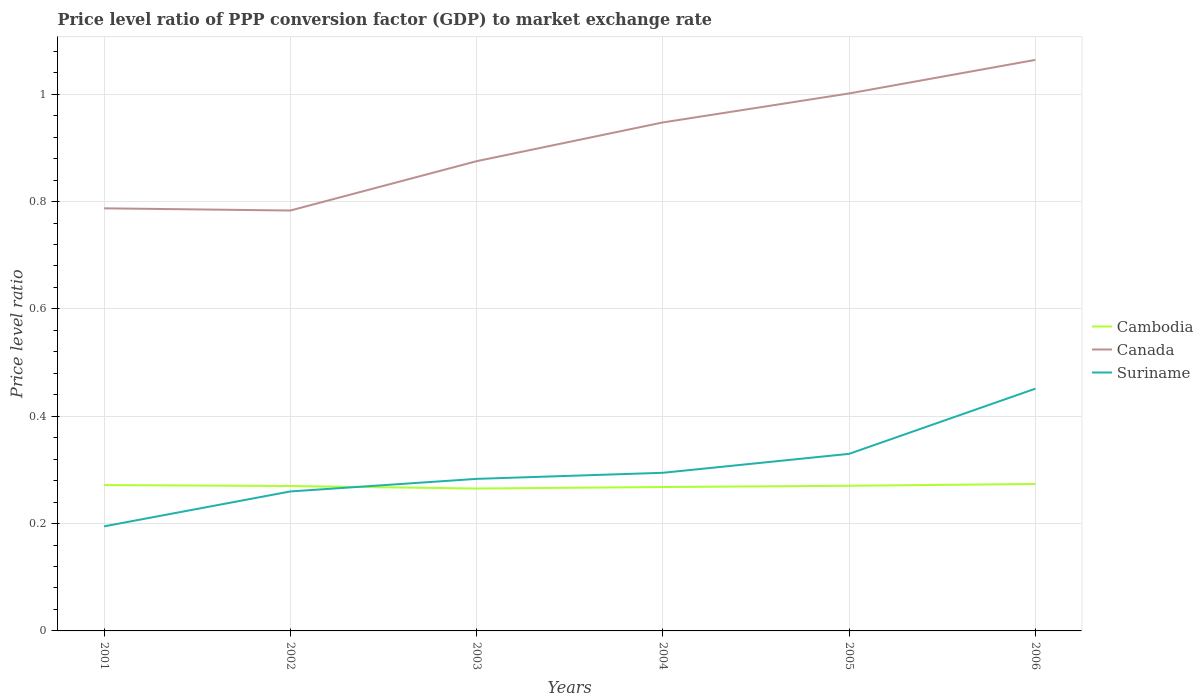How many different coloured lines are there?
Your response must be concise. 3. Is the number of lines equal to the number of legend labels?
Give a very brief answer. Yes. Across all years, what is the maximum price level ratio in Cambodia?
Your response must be concise. 0.27. In which year was the price level ratio in Suriname maximum?
Ensure brevity in your answer.  2001. What is the total price level ratio in Suriname in the graph?
Your answer should be compact. -0.1. What is the difference between the highest and the second highest price level ratio in Cambodia?
Keep it short and to the point. 0.01. What is the difference between the highest and the lowest price level ratio in Canada?
Provide a short and direct response. 3. How many years are there in the graph?
Make the answer very short. 6. What is the difference between two consecutive major ticks on the Y-axis?
Give a very brief answer. 0.2. Are the values on the major ticks of Y-axis written in scientific E-notation?
Make the answer very short. No. How many legend labels are there?
Offer a terse response. 3. How are the legend labels stacked?
Your response must be concise. Vertical. What is the title of the graph?
Your answer should be very brief. Price level ratio of PPP conversion factor (GDP) to market exchange rate. What is the label or title of the Y-axis?
Keep it short and to the point. Price level ratio. What is the Price level ratio of Cambodia in 2001?
Keep it short and to the point. 0.27. What is the Price level ratio in Canada in 2001?
Offer a very short reply. 0.79. What is the Price level ratio in Suriname in 2001?
Your answer should be very brief. 0.19. What is the Price level ratio in Cambodia in 2002?
Your answer should be compact. 0.27. What is the Price level ratio of Canada in 2002?
Provide a succinct answer. 0.78. What is the Price level ratio of Suriname in 2002?
Provide a succinct answer. 0.26. What is the Price level ratio of Cambodia in 2003?
Make the answer very short. 0.27. What is the Price level ratio of Canada in 2003?
Offer a terse response. 0.88. What is the Price level ratio in Suriname in 2003?
Provide a short and direct response. 0.28. What is the Price level ratio of Cambodia in 2004?
Give a very brief answer. 0.27. What is the Price level ratio in Canada in 2004?
Ensure brevity in your answer.  0.95. What is the Price level ratio in Suriname in 2004?
Provide a short and direct response. 0.29. What is the Price level ratio in Cambodia in 2005?
Offer a terse response. 0.27. What is the Price level ratio of Canada in 2005?
Offer a terse response. 1. What is the Price level ratio in Suriname in 2005?
Give a very brief answer. 0.33. What is the Price level ratio in Cambodia in 2006?
Provide a succinct answer. 0.27. What is the Price level ratio of Canada in 2006?
Give a very brief answer. 1.06. What is the Price level ratio in Suriname in 2006?
Your answer should be compact. 0.45. Across all years, what is the maximum Price level ratio in Cambodia?
Your response must be concise. 0.27. Across all years, what is the maximum Price level ratio in Canada?
Provide a succinct answer. 1.06. Across all years, what is the maximum Price level ratio of Suriname?
Give a very brief answer. 0.45. Across all years, what is the minimum Price level ratio of Cambodia?
Your answer should be compact. 0.27. Across all years, what is the minimum Price level ratio in Canada?
Offer a terse response. 0.78. Across all years, what is the minimum Price level ratio of Suriname?
Make the answer very short. 0.19. What is the total Price level ratio of Cambodia in the graph?
Offer a very short reply. 1.62. What is the total Price level ratio in Canada in the graph?
Your answer should be very brief. 5.46. What is the total Price level ratio in Suriname in the graph?
Make the answer very short. 1.81. What is the difference between the Price level ratio in Cambodia in 2001 and that in 2002?
Your response must be concise. 0. What is the difference between the Price level ratio in Canada in 2001 and that in 2002?
Give a very brief answer. 0. What is the difference between the Price level ratio of Suriname in 2001 and that in 2002?
Ensure brevity in your answer.  -0.07. What is the difference between the Price level ratio of Cambodia in 2001 and that in 2003?
Offer a very short reply. 0.01. What is the difference between the Price level ratio in Canada in 2001 and that in 2003?
Keep it short and to the point. -0.09. What is the difference between the Price level ratio of Suriname in 2001 and that in 2003?
Your answer should be compact. -0.09. What is the difference between the Price level ratio in Cambodia in 2001 and that in 2004?
Provide a succinct answer. 0. What is the difference between the Price level ratio in Canada in 2001 and that in 2004?
Offer a terse response. -0.16. What is the difference between the Price level ratio of Suriname in 2001 and that in 2004?
Your answer should be very brief. -0.1. What is the difference between the Price level ratio in Cambodia in 2001 and that in 2005?
Provide a short and direct response. 0. What is the difference between the Price level ratio in Canada in 2001 and that in 2005?
Your answer should be compact. -0.21. What is the difference between the Price level ratio of Suriname in 2001 and that in 2005?
Give a very brief answer. -0.14. What is the difference between the Price level ratio in Cambodia in 2001 and that in 2006?
Your answer should be compact. -0. What is the difference between the Price level ratio of Canada in 2001 and that in 2006?
Offer a very short reply. -0.28. What is the difference between the Price level ratio of Suriname in 2001 and that in 2006?
Make the answer very short. -0.26. What is the difference between the Price level ratio of Cambodia in 2002 and that in 2003?
Offer a terse response. 0. What is the difference between the Price level ratio of Canada in 2002 and that in 2003?
Offer a very short reply. -0.09. What is the difference between the Price level ratio of Suriname in 2002 and that in 2003?
Provide a succinct answer. -0.02. What is the difference between the Price level ratio of Cambodia in 2002 and that in 2004?
Ensure brevity in your answer.  0. What is the difference between the Price level ratio in Canada in 2002 and that in 2004?
Keep it short and to the point. -0.16. What is the difference between the Price level ratio in Suriname in 2002 and that in 2004?
Provide a succinct answer. -0.03. What is the difference between the Price level ratio of Cambodia in 2002 and that in 2005?
Keep it short and to the point. -0. What is the difference between the Price level ratio of Canada in 2002 and that in 2005?
Your answer should be compact. -0.22. What is the difference between the Price level ratio of Suriname in 2002 and that in 2005?
Offer a very short reply. -0.07. What is the difference between the Price level ratio in Cambodia in 2002 and that in 2006?
Your response must be concise. -0. What is the difference between the Price level ratio in Canada in 2002 and that in 2006?
Offer a terse response. -0.28. What is the difference between the Price level ratio of Suriname in 2002 and that in 2006?
Offer a very short reply. -0.19. What is the difference between the Price level ratio of Cambodia in 2003 and that in 2004?
Your response must be concise. -0. What is the difference between the Price level ratio of Canada in 2003 and that in 2004?
Provide a short and direct response. -0.07. What is the difference between the Price level ratio in Suriname in 2003 and that in 2004?
Offer a terse response. -0.01. What is the difference between the Price level ratio in Cambodia in 2003 and that in 2005?
Your answer should be compact. -0.01. What is the difference between the Price level ratio of Canada in 2003 and that in 2005?
Give a very brief answer. -0.13. What is the difference between the Price level ratio of Suriname in 2003 and that in 2005?
Give a very brief answer. -0.05. What is the difference between the Price level ratio of Cambodia in 2003 and that in 2006?
Provide a short and direct response. -0.01. What is the difference between the Price level ratio in Canada in 2003 and that in 2006?
Provide a short and direct response. -0.19. What is the difference between the Price level ratio in Suriname in 2003 and that in 2006?
Ensure brevity in your answer.  -0.17. What is the difference between the Price level ratio in Cambodia in 2004 and that in 2005?
Keep it short and to the point. -0. What is the difference between the Price level ratio in Canada in 2004 and that in 2005?
Your answer should be compact. -0.05. What is the difference between the Price level ratio of Suriname in 2004 and that in 2005?
Ensure brevity in your answer.  -0.04. What is the difference between the Price level ratio of Cambodia in 2004 and that in 2006?
Give a very brief answer. -0.01. What is the difference between the Price level ratio of Canada in 2004 and that in 2006?
Keep it short and to the point. -0.12. What is the difference between the Price level ratio of Suriname in 2004 and that in 2006?
Provide a short and direct response. -0.16. What is the difference between the Price level ratio in Cambodia in 2005 and that in 2006?
Provide a short and direct response. -0. What is the difference between the Price level ratio of Canada in 2005 and that in 2006?
Offer a terse response. -0.06. What is the difference between the Price level ratio of Suriname in 2005 and that in 2006?
Provide a short and direct response. -0.12. What is the difference between the Price level ratio of Cambodia in 2001 and the Price level ratio of Canada in 2002?
Offer a very short reply. -0.51. What is the difference between the Price level ratio of Cambodia in 2001 and the Price level ratio of Suriname in 2002?
Provide a succinct answer. 0.01. What is the difference between the Price level ratio in Canada in 2001 and the Price level ratio in Suriname in 2002?
Provide a short and direct response. 0.53. What is the difference between the Price level ratio in Cambodia in 2001 and the Price level ratio in Canada in 2003?
Your answer should be very brief. -0.6. What is the difference between the Price level ratio in Cambodia in 2001 and the Price level ratio in Suriname in 2003?
Make the answer very short. -0.01. What is the difference between the Price level ratio of Canada in 2001 and the Price level ratio of Suriname in 2003?
Provide a short and direct response. 0.5. What is the difference between the Price level ratio in Cambodia in 2001 and the Price level ratio in Canada in 2004?
Give a very brief answer. -0.68. What is the difference between the Price level ratio of Cambodia in 2001 and the Price level ratio of Suriname in 2004?
Offer a very short reply. -0.02. What is the difference between the Price level ratio in Canada in 2001 and the Price level ratio in Suriname in 2004?
Ensure brevity in your answer.  0.49. What is the difference between the Price level ratio in Cambodia in 2001 and the Price level ratio in Canada in 2005?
Your answer should be very brief. -0.73. What is the difference between the Price level ratio of Cambodia in 2001 and the Price level ratio of Suriname in 2005?
Your answer should be very brief. -0.06. What is the difference between the Price level ratio in Canada in 2001 and the Price level ratio in Suriname in 2005?
Offer a very short reply. 0.46. What is the difference between the Price level ratio of Cambodia in 2001 and the Price level ratio of Canada in 2006?
Provide a short and direct response. -0.79. What is the difference between the Price level ratio in Cambodia in 2001 and the Price level ratio in Suriname in 2006?
Offer a very short reply. -0.18. What is the difference between the Price level ratio of Canada in 2001 and the Price level ratio of Suriname in 2006?
Offer a terse response. 0.34. What is the difference between the Price level ratio of Cambodia in 2002 and the Price level ratio of Canada in 2003?
Your answer should be compact. -0.61. What is the difference between the Price level ratio in Cambodia in 2002 and the Price level ratio in Suriname in 2003?
Provide a short and direct response. -0.01. What is the difference between the Price level ratio of Cambodia in 2002 and the Price level ratio of Canada in 2004?
Ensure brevity in your answer.  -0.68. What is the difference between the Price level ratio in Cambodia in 2002 and the Price level ratio in Suriname in 2004?
Make the answer very short. -0.02. What is the difference between the Price level ratio in Canada in 2002 and the Price level ratio in Suriname in 2004?
Give a very brief answer. 0.49. What is the difference between the Price level ratio in Cambodia in 2002 and the Price level ratio in Canada in 2005?
Provide a succinct answer. -0.73. What is the difference between the Price level ratio in Cambodia in 2002 and the Price level ratio in Suriname in 2005?
Ensure brevity in your answer.  -0.06. What is the difference between the Price level ratio in Canada in 2002 and the Price level ratio in Suriname in 2005?
Your response must be concise. 0.45. What is the difference between the Price level ratio of Cambodia in 2002 and the Price level ratio of Canada in 2006?
Give a very brief answer. -0.79. What is the difference between the Price level ratio in Cambodia in 2002 and the Price level ratio in Suriname in 2006?
Keep it short and to the point. -0.18. What is the difference between the Price level ratio of Canada in 2002 and the Price level ratio of Suriname in 2006?
Your answer should be compact. 0.33. What is the difference between the Price level ratio of Cambodia in 2003 and the Price level ratio of Canada in 2004?
Provide a short and direct response. -0.68. What is the difference between the Price level ratio of Cambodia in 2003 and the Price level ratio of Suriname in 2004?
Provide a short and direct response. -0.03. What is the difference between the Price level ratio in Canada in 2003 and the Price level ratio in Suriname in 2004?
Your answer should be very brief. 0.58. What is the difference between the Price level ratio of Cambodia in 2003 and the Price level ratio of Canada in 2005?
Your response must be concise. -0.74. What is the difference between the Price level ratio in Cambodia in 2003 and the Price level ratio in Suriname in 2005?
Provide a succinct answer. -0.06. What is the difference between the Price level ratio of Canada in 2003 and the Price level ratio of Suriname in 2005?
Make the answer very short. 0.55. What is the difference between the Price level ratio in Cambodia in 2003 and the Price level ratio in Canada in 2006?
Offer a very short reply. -0.8. What is the difference between the Price level ratio in Cambodia in 2003 and the Price level ratio in Suriname in 2006?
Give a very brief answer. -0.19. What is the difference between the Price level ratio in Canada in 2003 and the Price level ratio in Suriname in 2006?
Give a very brief answer. 0.42. What is the difference between the Price level ratio in Cambodia in 2004 and the Price level ratio in Canada in 2005?
Give a very brief answer. -0.73. What is the difference between the Price level ratio of Cambodia in 2004 and the Price level ratio of Suriname in 2005?
Provide a short and direct response. -0.06. What is the difference between the Price level ratio of Canada in 2004 and the Price level ratio of Suriname in 2005?
Your answer should be very brief. 0.62. What is the difference between the Price level ratio of Cambodia in 2004 and the Price level ratio of Canada in 2006?
Offer a very short reply. -0.8. What is the difference between the Price level ratio of Cambodia in 2004 and the Price level ratio of Suriname in 2006?
Give a very brief answer. -0.18. What is the difference between the Price level ratio of Canada in 2004 and the Price level ratio of Suriname in 2006?
Give a very brief answer. 0.5. What is the difference between the Price level ratio of Cambodia in 2005 and the Price level ratio of Canada in 2006?
Keep it short and to the point. -0.79. What is the difference between the Price level ratio of Cambodia in 2005 and the Price level ratio of Suriname in 2006?
Ensure brevity in your answer.  -0.18. What is the difference between the Price level ratio in Canada in 2005 and the Price level ratio in Suriname in 2006?
Make the answer very short. 0.55. What is the average Price level ratio of Cambodia per year?
Provide a succinct answer. 0.27. What is the average Price level ratio of Canada per year?
Keep it short and to the point. 0.91. What is the average Price level ratio in Suriname per year?
Provide a succinct answer. 0.3. In the year 2001, what is the difference between the Price level ratio of Cambodia and Price level ratio of Canada?
Offer a very short reply. -0.52. In the year 2001, what is the difference between the Price level ratio in Cambodia and Price level ratio in Suriname?
Your answer should be very brief. 0.08. In the year 2001, what is the difference between the Price level ratio of Canada and Price level ratio of Suriname?
Your answer should be very brief. 0.59. In the year 2002, what is the difference between the Price level ratio in Cambodia and Price level ratio in Canada?
Make the answer very short. -0.51. In the year 2002, what is the difference between the Price level ratio in Cambodia and Price level ratio in Suriname?
Offer a very short reply. 0.01. In the year 2002, what is the difference between the Price level ratio in Canada and Price level ratio in Suriname?
Your answer should be compact. 0.52. In the year 2003, what is the difference between the Price level ratio in Cambodia and Price level ratio in Canada?
Provide a short and direct response. -0.61. In the year 2003, what is the difference between the Price level ratio in Cambodia and Price level ratio in Suriname?
Give a very brief answer. -0.02. In the year 2003, what is the difference between the Price level ratio of Canada and Price level ratio of Suriname?
Your answer should be compact. 0.59. In the year 2004, what is the difference between the Price level ratio in Cambodia and Price level ratio in Canada?
Offer a very short reply. -0.68. In the year 2004, what is the difference between the Price level ratio in Cambodia and Price level ratio in Suriname?
Your response must be concise. -0.03. In the year 2004, what is the difference between the Price level ratio of Canada and Price level ratio of Suriname?
Provide a succinct answer. 0.65. In the year 2005, what is the difference between the Price level ratio in Cambodia and Price level ratio in Canada?
Give a very brief answer. -0.73. In the year 2005, what is the difference between the Price level ratio in Cambodia and Price level ratio in Suriname?
Make the answer very short. -0.06. In the year 2005, what is the difference between the Price level ratio of Canada and Price level ratio of Suriname?
Provide a short and direct response. 0.67. In the year 2006, what is the difference between the Price level ratio in Cambodia and Price level ratio in Canada?
Offer a very short reply. -0.79. In the year 2006, what is the difference between the Price level ratio of Cambodia and Price level ratio of Suriname?
Your answer should be very brief. -0.18. In the year 2006, what is the difference between the Price level ratio in Canada and Price level ratio in Suriname?
Your answer should be very brief. 0.61. What is the ratio of the Price level ratio of Canada in 2001 to that in 2002?
Your answer should be compact. 1.01. What is the ratio of the Price level ratio of Suriname in 2001 to that in 2002?
Provide a succinct answer. 0.75. What is the ratio of the Price level ratio in Cambodia in 2001 to that in 2003?
Keep it short and to the point. 1.02. What is the ratio of the Price level ratio in Canada in 2001 to that in 2003?
Make the answer very short. 0.9. What is the ratio of the Price level ratio in Suriname in 2001 to that in 2003?
Provide a short and direct response. 0.69. What is the ratio of the Price level ratio in Cambodia in 2001 to that in 2004?
Offer a terse response. 1.01. What is the ratio of the Price level ratio in Canada in 2001 to that in 2004?
Offer a very short reply. 0.83. What is the ratio of the Price level ratio in Suriname in 2001 to that in 2004?
Provide a short and direct response. 0.66. What is the ratio of the Price level ratio of Canada in 2001 to that in 2005?
Offer a terse response. 0.79. What is the ratio of the Price level ratio in Suriname in 2001 to that in 2005?
Your answer should be very brief. 0.59. What is the ratio of the Price level ratio in Cambodia in 2001 to that in 2006?
Make the answer very short. 0.99. What is the ratio of the Price level ratio of Canada in 2001 to that in 2006?
Offer a terse response. 0.74. What is the ratio of the Price level ratio of Suriname in 2001 to that in 2006?
Your answer should be very brief. 0.43. What is the ratio of the Price level ratio of Cambodia in 2002 to that in 2003?
Keep it short and to the point. 1.02. What is the ratio of the Price level ratio of Canada in 2002 to that in 2003?
Ensure brevity in your answer.  0.9. What is the ratio of the Price level ratio of Suriname in 2002 to that in 2003?
Your answer should be compact. 0.92. What is the ratio of the Price level ratio in Canada in 2002 to that in 2004?
Give a very brief answer. 0.83. What is the ratio of the Price level ratio of Suriname in 2002 to that in 2004?
Make the answer very short. 0.88. What is the ratio of the Price level ratio in Canada in 2002 to that in 2005?
Your answer should be very brief. 0.78. What is the ratio of the Price level ratio in Suriname in 2002 to that in 2005?
Keep it short and to the point. 0.79. What is the ratio of the Price level ratio of Cambodia in 2002 to that in 2006?
Keep it short and to the point. 0.99. What is the ratio of the Price level ratio of Canada in 2002 to that in 2006?
Offer a terse response. 0.74. What is the ratio of the Price level ratio of Suriname in 2002 to that in 2006?
Offer a terse response. 0.58. What is the ratio of the Price level ratio in Cambodia in 2003 to that in 2004?
Your answer should be compact. 0.99. What is the ratio of the Price level ratio in Canada in 2003 to that in 2004?
Your answer should be compact. 0.92. What is the ratio of the Price level ratio of Suriname in 2003 to that in 2004?
Ensure brevity in your answer.  0.96. What is the ratio of the Price level ratio of Cambodia in 2003 to that in 2005?
Keep it short and to the point. 0.98. What is the ratio of the Price level ratio of Canada in 2003 to that in 2005?
Provide a succinct answer. 0.87. What is the ratio of the Price level ratio in Suriname in 2003 to that in 2005?
Provide a short and direct response. 0.86. What is the ratio of the Price level ratio of Cambodia in 2003 to that in 2006?
Your answer should be very brief. 0.97. What is the ratio of the Price level ratio of Canada in 2003 to that in 2006?
Offer a very short reply. 0.82. What is the ratio of the Price level ratio of Suriname in 2003 to that in 2006?
Offer a terse response. 0.63. What is the ratio of the Price level ratio in Canada in 2004 to that in 2005?
Ensure brevity in your answer.  0.95. What is the ratio of the Price level ratio in Suriname in 2004 to that in 2005?
Make the answer very short. 0.89. What is the ratio of the Price level ratio in Cambodia in 2004 to that in 2006?
Keep it short and to the point. 0.98. What is the ratio of the Price level ratio of Canada in 2004 to that in 2006?
Provide a succinct answer. 0.89. What is the ratio of the Price level ratio in Suriname in 2004 to that in 2006?
Offer a terse response. 0.65. What is the ratio of the Price level ratio in Cambodia in 2005 to that in 2006?
Provide a succinct answer. 0.99. What is the ratio of the Price level ratio in Canada in 2005 to that in 2006?
Keep it short and to the point. 0.94. What is the ratio of the Price level ratio of Suriname in 2005 to that in 2006?
Provide a short and direct response. 0.73. What is the difference between the highest and the second highest Price level ratio in Cambodia?
Keep it short and to the point. 0. What is the difference between the highest and the second highest Price level ratio of Canada?
Your answer should be compact. 0.06. What is the difference between the highest and the second highest Price level ratio of Suriname?
Give a very brief answer. 0.12. What is the difference between the highest and the lowest Price level ratio of Cambodia?
Provide a short and direct response. 0.01. What is the difference between the highest and the lowest Price level ratio in Canada?
Provide a succinct answer. 0.28. What is the difference between the highest and the lowest Price level ratio in Suriname?
Give a very brief answer. 0.26. 